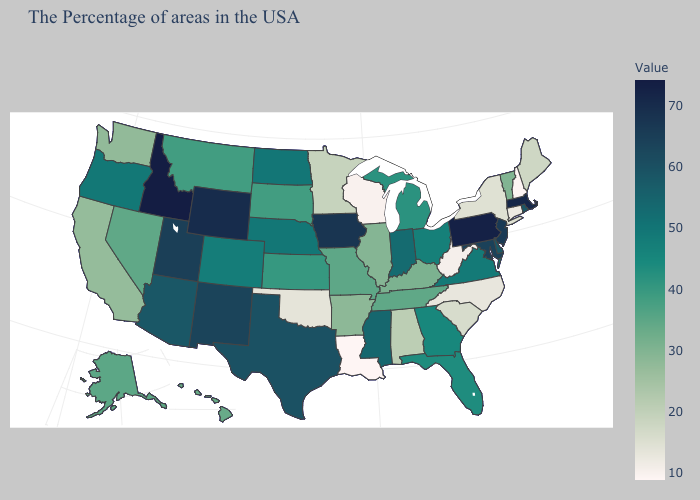Among the states that border Mississippi , which have the highest value?
Keep it brief. Tennessee. Does Arkansas have the highest value in the USA?
Keep it brief. No. Which states have the lowest value in the USA?
Be succinct. Louisiana. Among the states that border Mississippi , which have the lowest value?
Be succinct. Louisiana. Which states have the lowest value in the USA?
Be succinct. Louisiana. 